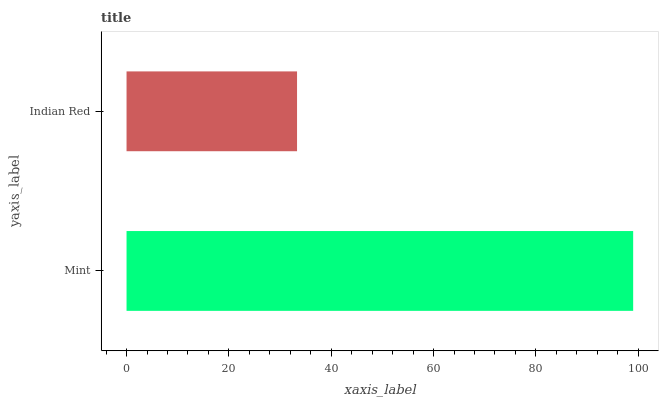Is Indian Red the minimum?
Answer yes or no. Yes. Is Mint the maximum?
Answer yes or no. Yes. Is Indian Red the maximum?
Answer yes or no. No. Is Mint greater than Indian Red?
Answer yes or no. Yes. Is Indian Red less than Mint?
Answer yes or no. Yes. Is Indian Red greater than Mint?
Answer yes or no. No. Is Mint less than Indian Red?
Answer yes or no. No. Is Mint the high median?
Answer yes or no. Yes. Is Indian Red the low median?
Answer yes or no. Yes. Is Indian Red the high median?
Answer yes or no. No. Is Mint the low median?
Answer yes or no. No. 